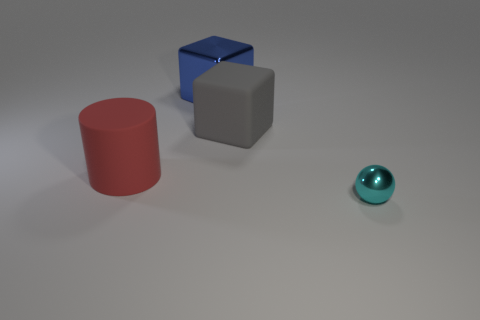What is the lighting like in the image? The lighting in the image seems to be coming from above, creating soft shadows beneath the objects which suggests an indoor setting with diffused light, likely from an artificial source. Does the lighting affect the colors of the objects? Yes, the lighting affects the appearance of the objects' colors, with the shadows slightly muting the colors and the light areas appearing more vibrant. The shiny surface of the cyan sphere particularly reflects the light, giving it a luminous quality. 